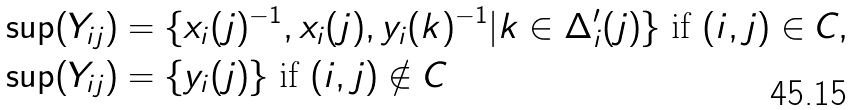<formula> <loc_0><loc_0><loc_500><loc_500>\sup ( Y _ { i j } ) & = \{ x _ { i } ( j ) ^ { - 1 } , x _ { i } ( j ) , y _ { i } ( k ) ^ { - 1 } | k \in \Delta _ { i } ^ { \prime } ( j ) \} \text { if } ( i , j ) \in C , \\ \sup ( Y _ { i j } ) & = \{ y _ { i } ( j ) \} \text { if } ( i , j ) \notin C</formula> 